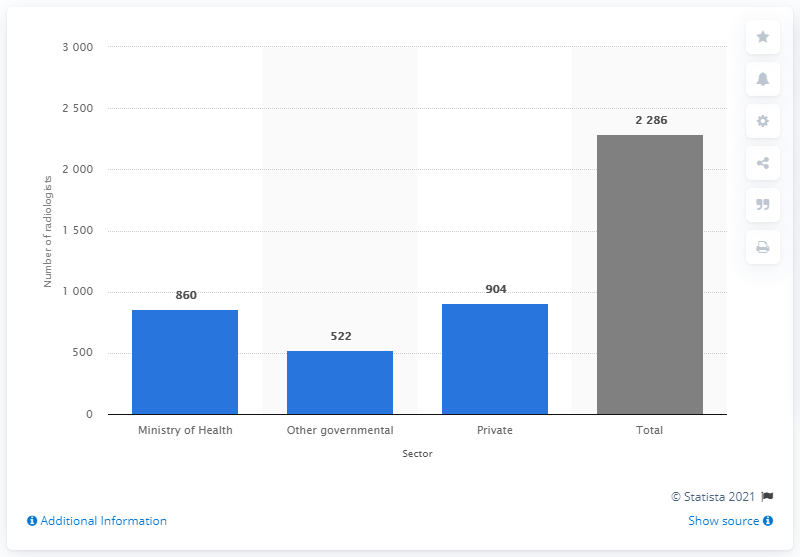Mention a couple of crucial points in this snapshot. The Ministry of Health was responsible for the number of radiologists in Saudi Arabia in 2016. As of 2016, there were 860 radiologists who were employed by the Ministry of Health in Saudi Arabia. 